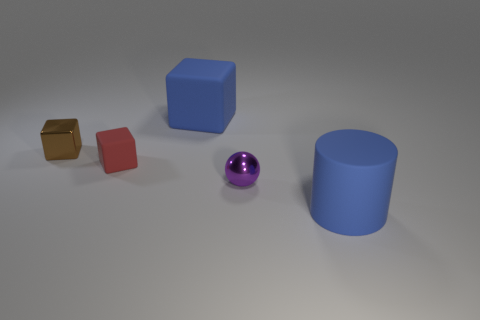Add 5 tiny red cubes. How many objects exist? 10 Subtract all cylinders. How many objects are left? 4 Subtract 0 green blocks. How many objects are left? 5 Subtract all gray matte cylinders. Subtract all large cubes. How many objects are left? 4 Add 5 metal balls. How many metal balls are left? 6 Add 4 cylinders. How many cylinders exist? 5 